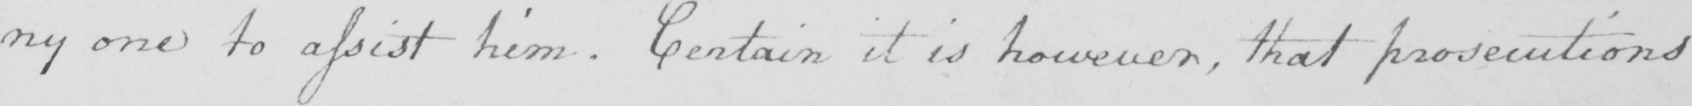What text is written in this handwritten line? : ny one to assist him . Certain it is however , that prosecutions 